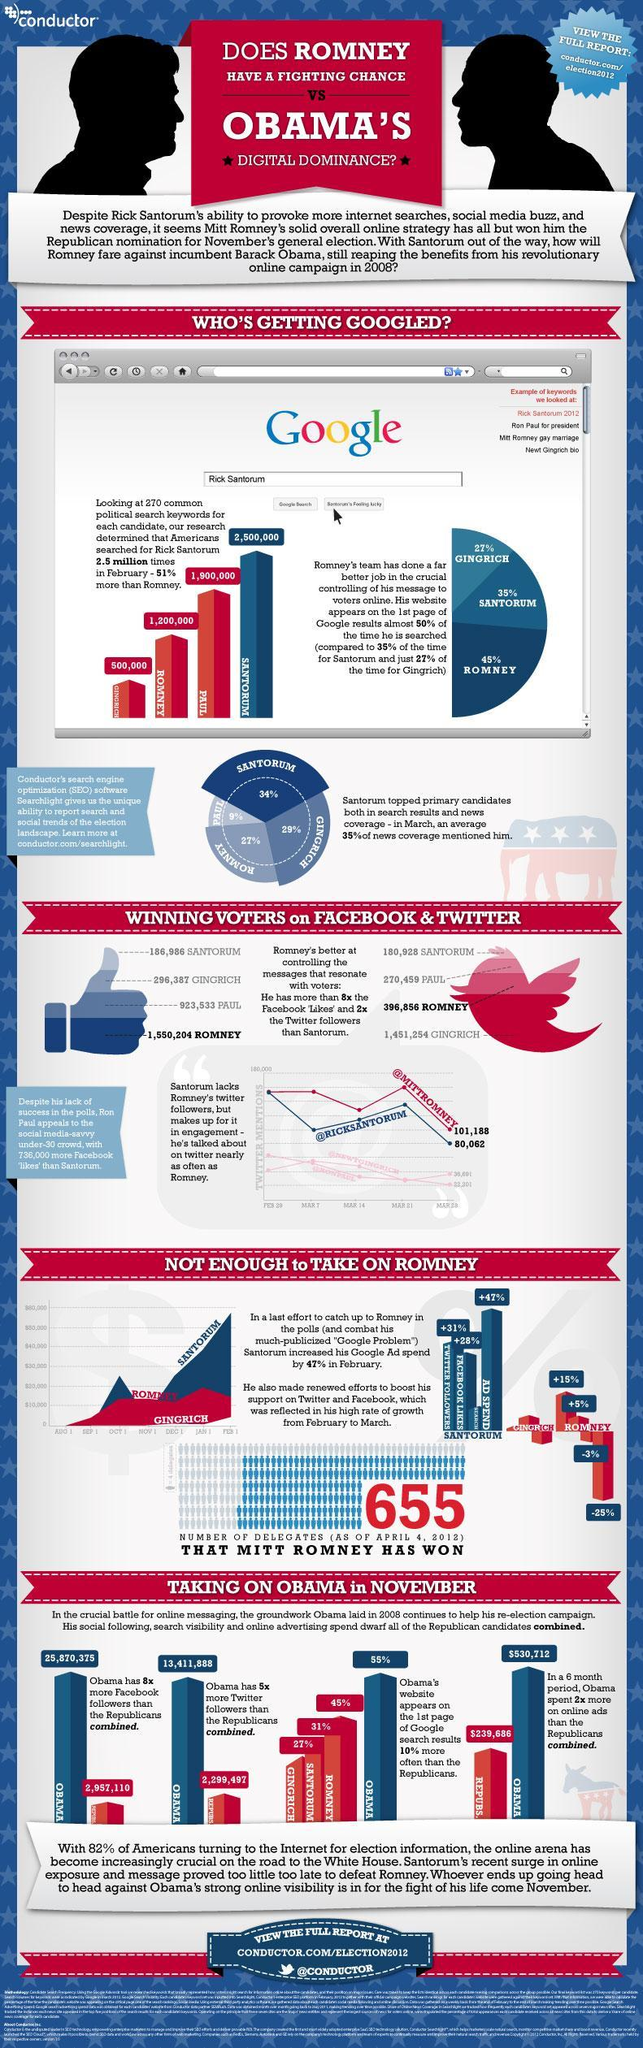Which Republican's website appeared 14% higher than Rick Santorum's site ?
Answer the question with a short phrase. Romney What was the search percentage of Romney during February and March? -3% What was Mitt Romney's Ad spend on January 1st? $20,000 What was the ad spend percentage of Romney during February and March? -25% What was the second lowest number of voters through Facebook? 296,387 Who was found to be the second most mentions in news and web search results? Gingrich What was the lowest number of voters through Twitter? 270,459 How many more times did Rick Santorum appear as a keyword in comparison to Gingrich? 2,000,000 